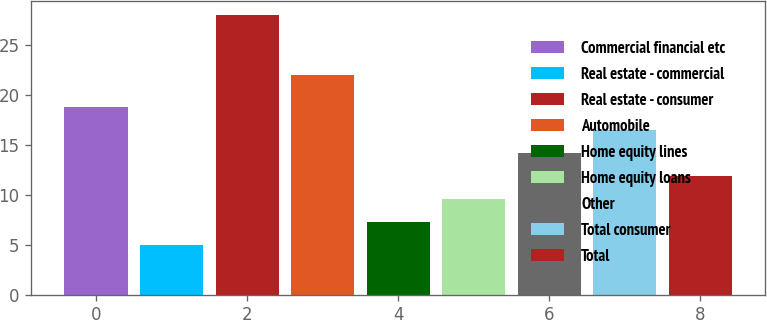<chart> <loc_0><loc_0><loc_500><loc_500><bar_chart><fcel>Commercial financial etc<fcel>Real estate - commercial<fcel>Real estate - consumer<fcel>Automobile<fcel>Home equity lines<fcel>Home equity loans<fcel>Other<fcel>Total consumer<fcel>Total<nl><fcel>18.8<fcel>5<fcel>28<fcel>22<fcel>7.3<fcel>9.6<fcel>14.2<fcel>16.5<fcel>11.9<nl></chart> 